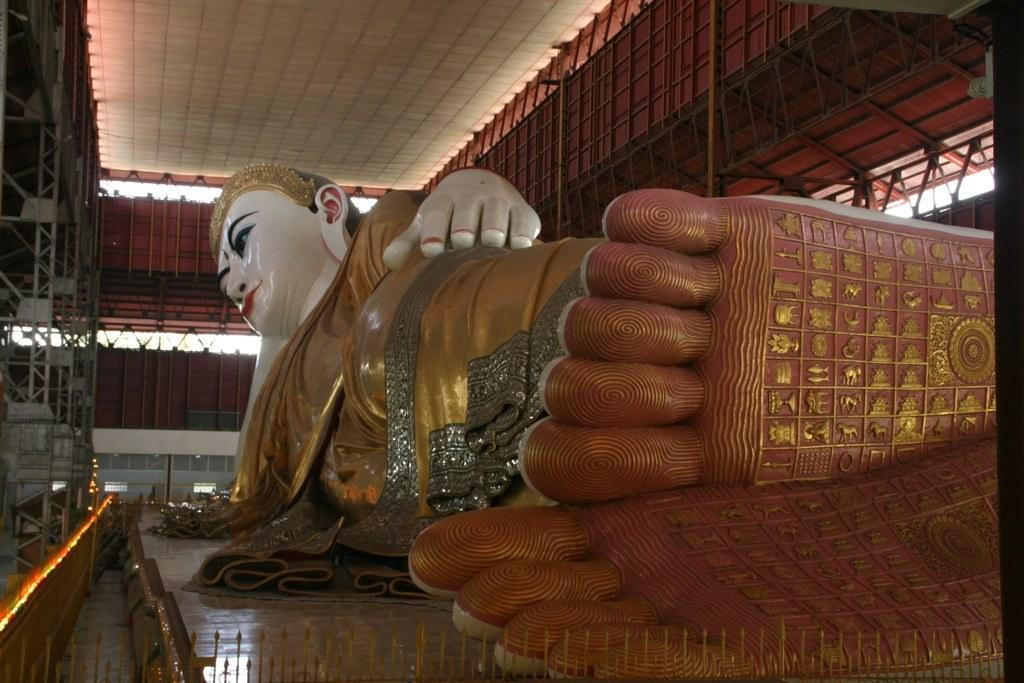What is the main subject of the image? There is a statue in the image. Can you describe the statue? The statue is of a man. What is the color of the statue? The statue has a gold color. How many roses are surrounding the statue in the image? There are no roses present in the image; it only features a gold statue of a man. 